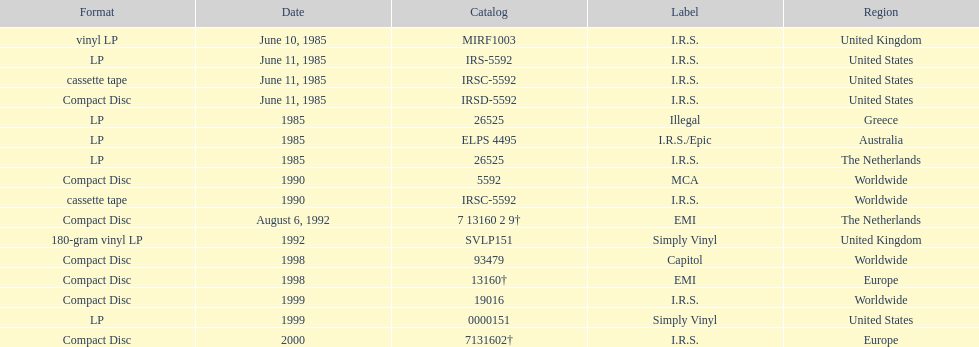Which country or region had the most releases? Worldwide. Would you mind parsing the complete table? {'header': ['Format', 'Date', 'Catalog', 'Label', 'Region'], 'rows': [['vinyl LP', 'June 10, 1985', 'MIRF1003', 'I.R.S.', 'United Kingdom'], ['LP', 'June 11, 1985', 'IRS-5592', 'I.R.S.', 'United States'], ['cassette tape', 'June 11, 1985', 'IRSC-5592', 'I.R.S.', 'United States'], ['Compact Disc', 'June 11, 1985', 'IRSD-5592', 'I.R.S.', 'United States'], ['LP', '1985', '26525', 'Illegal', 'Greece'], ['LP', '1985', 'ELPS 4495', 'I.R.S./Epic', 'Australia'], ['LP', '1985', '26525', 'I.R.S.', 'The Netherlands'], ['Compact Disc', '1990', '5592', 'MCA', 'Worldwide'], ['cassette tape', '1990', 'IRSC-5592', 'I.R.S.', 'Worldwide'], ['Compact Disc', 'August 6, 1992', '7 13160 2 9†', 'EMI', 'The Netherlands'], ['180-gram vinyl LP', '1992', 'SVLP151', 'Simply Vinyl', 'United Kingdom'], ['Compact Disc', '1998', '93479', 'Capitol', 'Worldwide'], ['Compact Disc', '1998', '13160†', 'EMI', 'Europe'], ['Compact Disc', '1999', '19016', 'I.R.S.', 'Worldwide'], ['LP', '1999', '0000151', 'Simply Vinyl', 'United States'], ['Compact Disc', '2000', '7131602†', 'I.R.S.', 'Europe']]} 